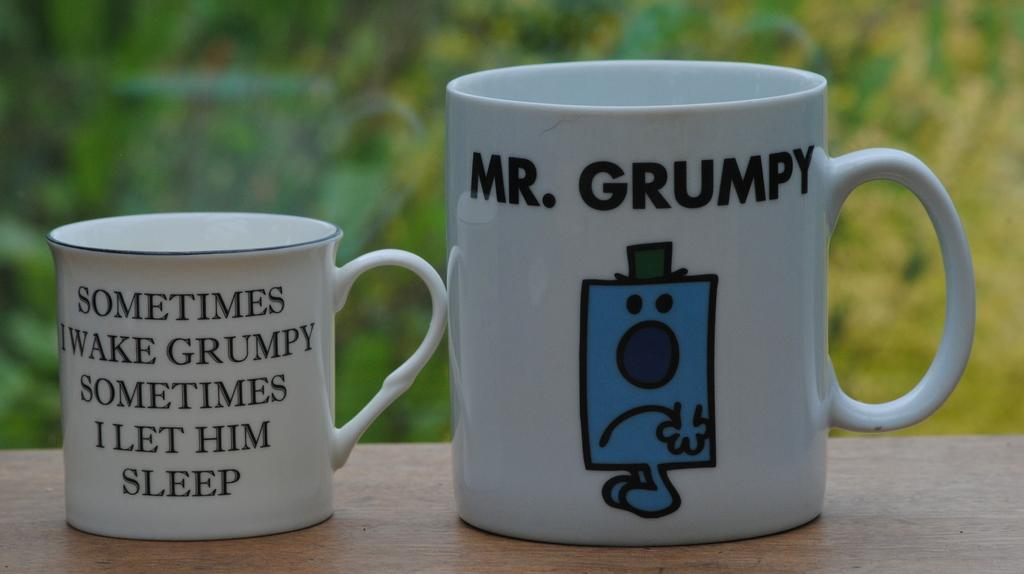<image>
Render a clear and concise summary of the photo. Two cups next to one another with one saying "Mr. Grumpy". 